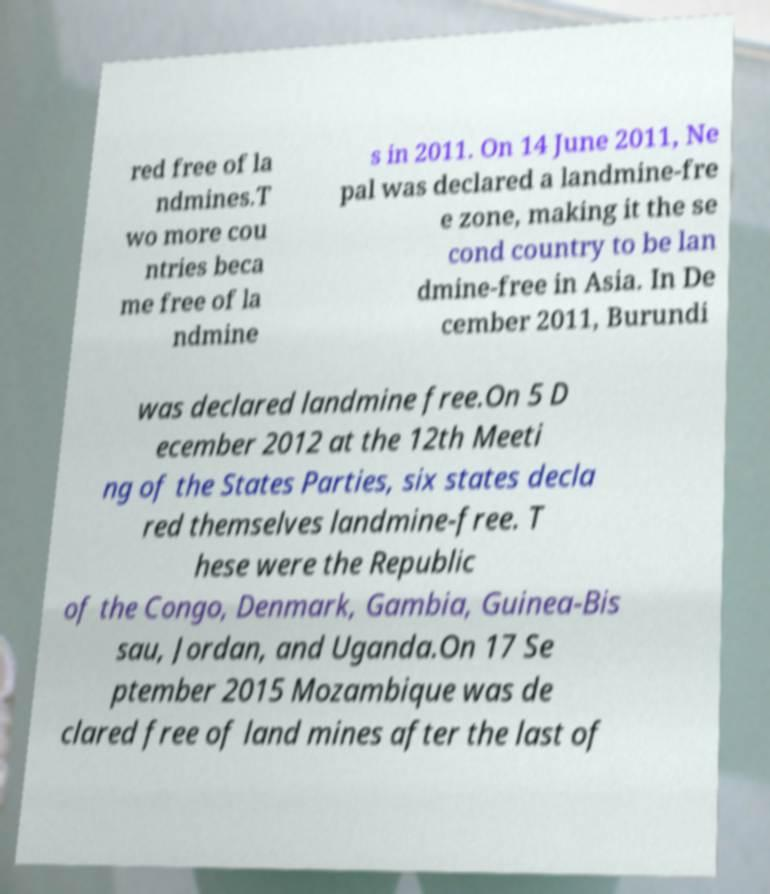Can you accurately transcribe the text from the provided image for me? red free of la ndmines.T wo more cou ntries beca me free of la ndmine s in 2011. On 14 June 2011, Ne pal was declared a landmine-fre e zone, making it the se cond country to be lan dmine-free in Asia. In De cember 2011, Burundi was declared landmine free.On 5 D ecember 2012 at the 12th Meeti ng of the States Parties, six states decla red themselves landmine-free. T hese were the Republic of the Congo, Denmark, Gambia, Guinea-Bis sau, Jordan, and Uganda.On 17 Se ptember 2015 Mozambique was de clared free of land mines after the last of 